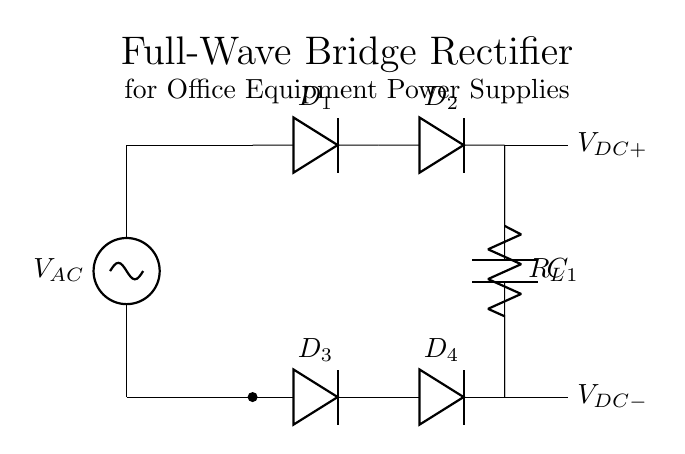What type of rectifier is this circuit? The circuit is labeled as a "Full-Wave Bridge Rectifier," which indicates that it converts alternating current (AC) into direct current (DC) using four diodes arranged in a bridge configuration.
Answer: Full-Wave Bridge Rectifier How many diodes are used in this circuit? The diagram shows a total of four diodes labeled D1, D2, D3, and D4, indicating that four diodes are part of the bridge rectifier configuration to rectify the AC input.
Answer: Four What is the purpose of the capacitor in this circuit? The capacitor, labeled C1, is used to smooth the output voltage by filtering out the ripples from the rectified DC voltage, providing a more stable and steady DC output.
Answer: Smooth the output voltage What is the relationship between V_AC and V_DC in this circuit? The alternating current voltage (V_AC) is transformed into direct current voltage (V_DC) after rectification. The peak voltage of V_AC is typically higher than the resulting V_DC after smoothing.
Answer: V_DC is lower than V_AC Where is the load resistor located in this circuit? The load resistor labeled R_L is connected in parallel between the output of the smoothing capacitor (C1) and ground, allowing current to flow through the load when powered by the output DC.
Answer: Right of the capacitor What happens to the current direction during the positive half-cycle of AC? During the positive half-cycle of the AC voltage, current flows through diodes D1 and D2, allowing current to pass through the load resistor and charge the capacitor, which contributes to the output DC voltage.
Answer: Flows through D1 and D2 How does this circuit achieve full-wave rectification? Full-wave rectification is achieved by the arrangement of diodes in a bridge configuration, allowing both halves of the AC waveform to be used. When AC voltage goes positive, two diodes conduct; when it goes negative, the other two do, creating a continuous DC output.
Answer: Bridge configuration of diodes 